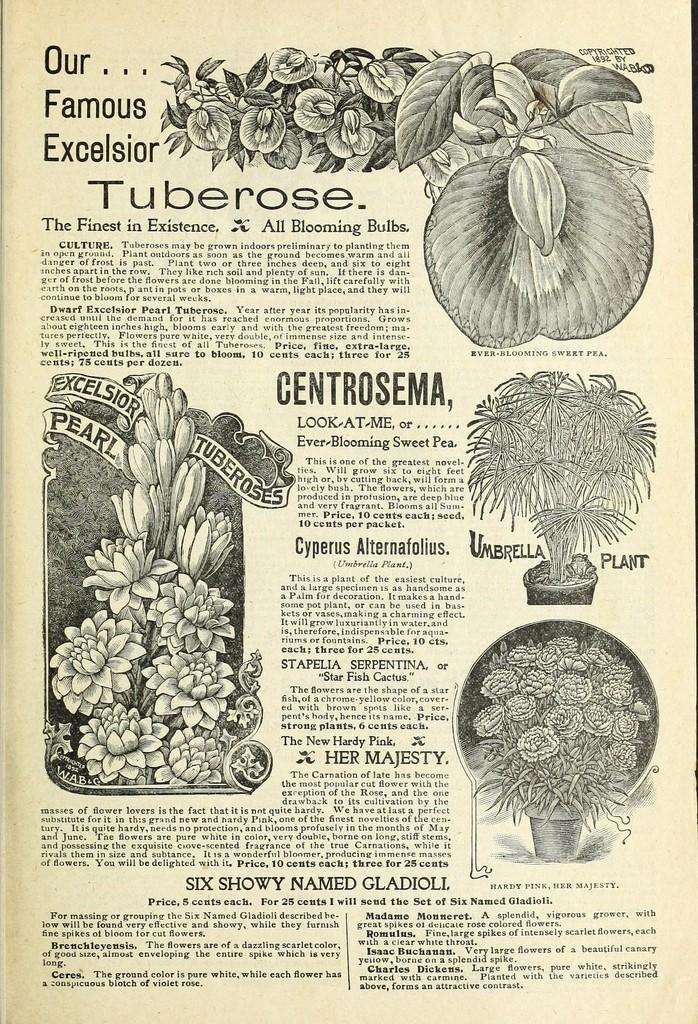What type of paper is present in the image? There is a magazine paper in the image. What other objects can be seen in the image? Plants and a rose pot are visible in the image. What is written at the top of the image? The word "Tuberose" is written at the top of the image. What type of lamp is visible in the image? There is no lamp present in the image. What type of vegetable is growing in the image? The image does not show any vegetables; it features plants and a rose pot. 